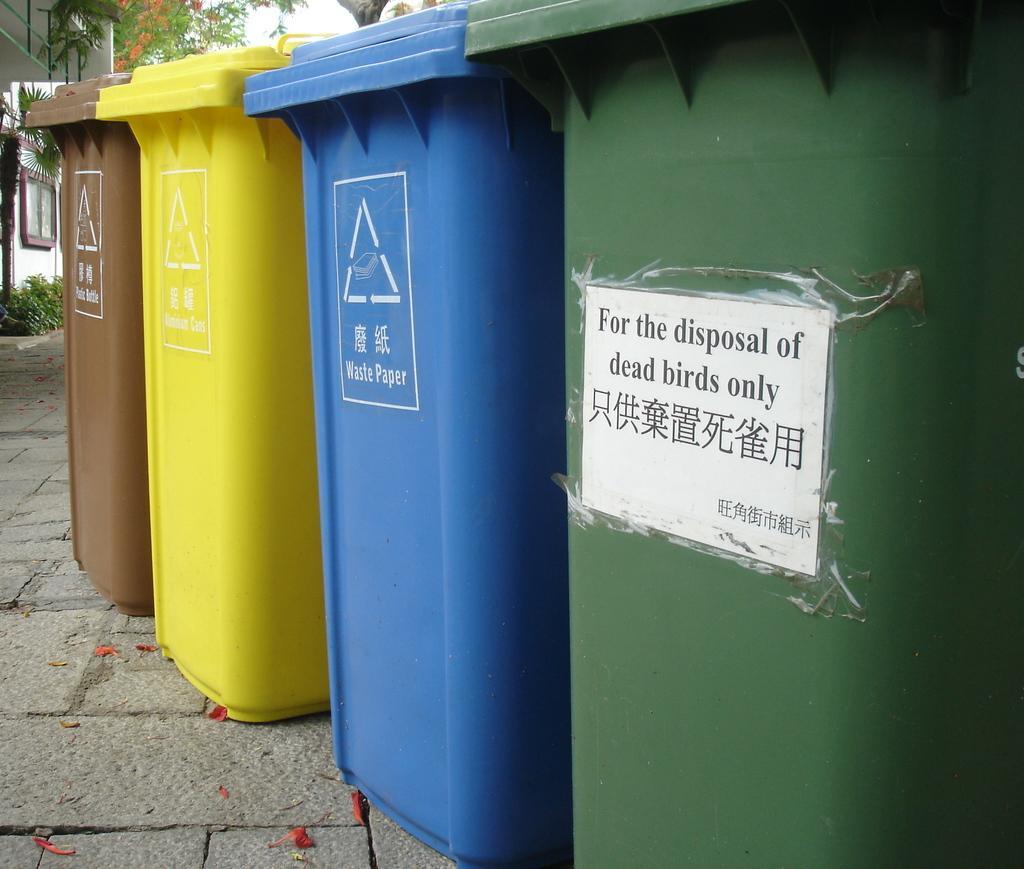Please provide a concise description of this image. In the center of the image we can see four dustbins, which are in brown, yellow, blue and green color. On the dustbins, we can see the banners. On the banners, we can see some text. In the background we can see the sky, trees, plants, one building, window and a few other objects. 